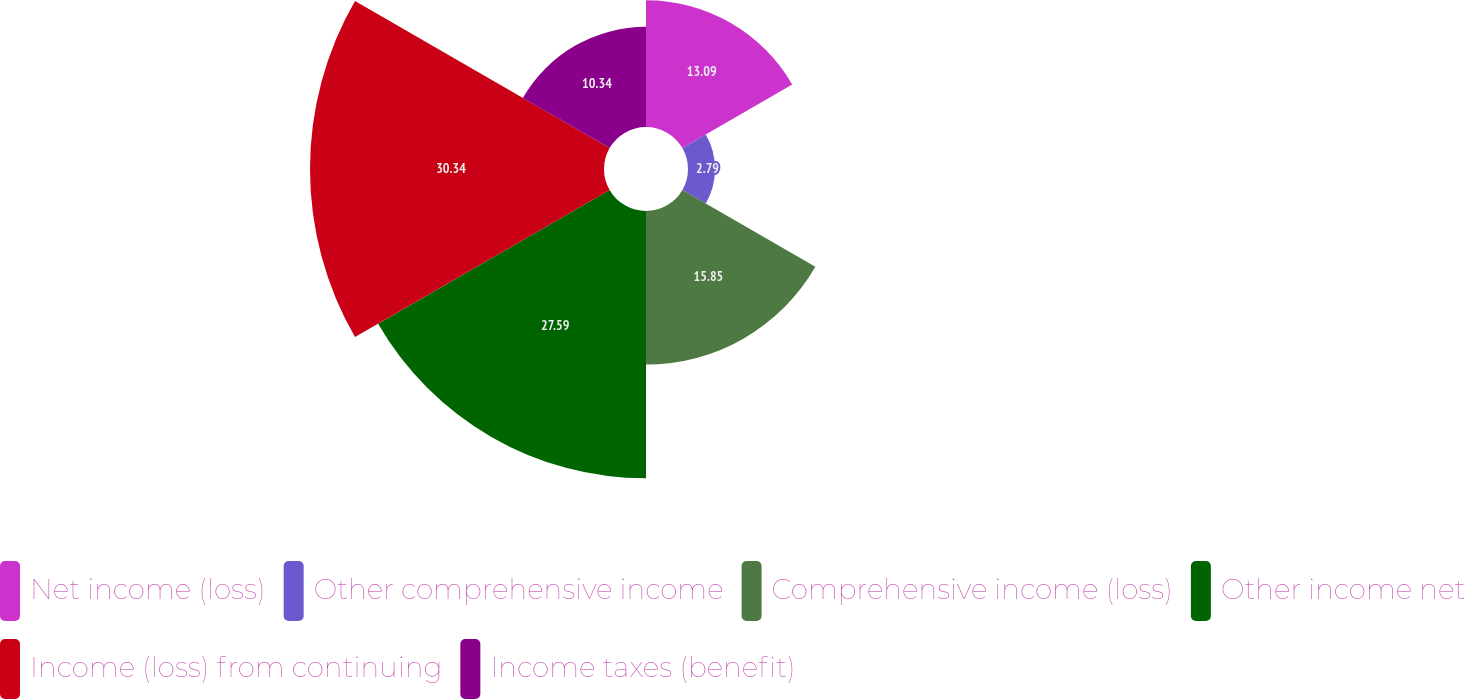Convert chart. <chart><loc_0><loc_0><loc_500><loc_500><pie_chart><fcel>Net income (loss)<fcel>Other comprehensive income<fcel>Comprehensive income (loss)<fcel>Other income net<fcel>Income (loss) from continuing<fcel>Income taxes (benefit)<nl><fcel>13.09%<fcel>2.79%<fcel>15.85%<fcel>27.59%<fcel>30.34%<fcel>10.34%<nl></chart> 